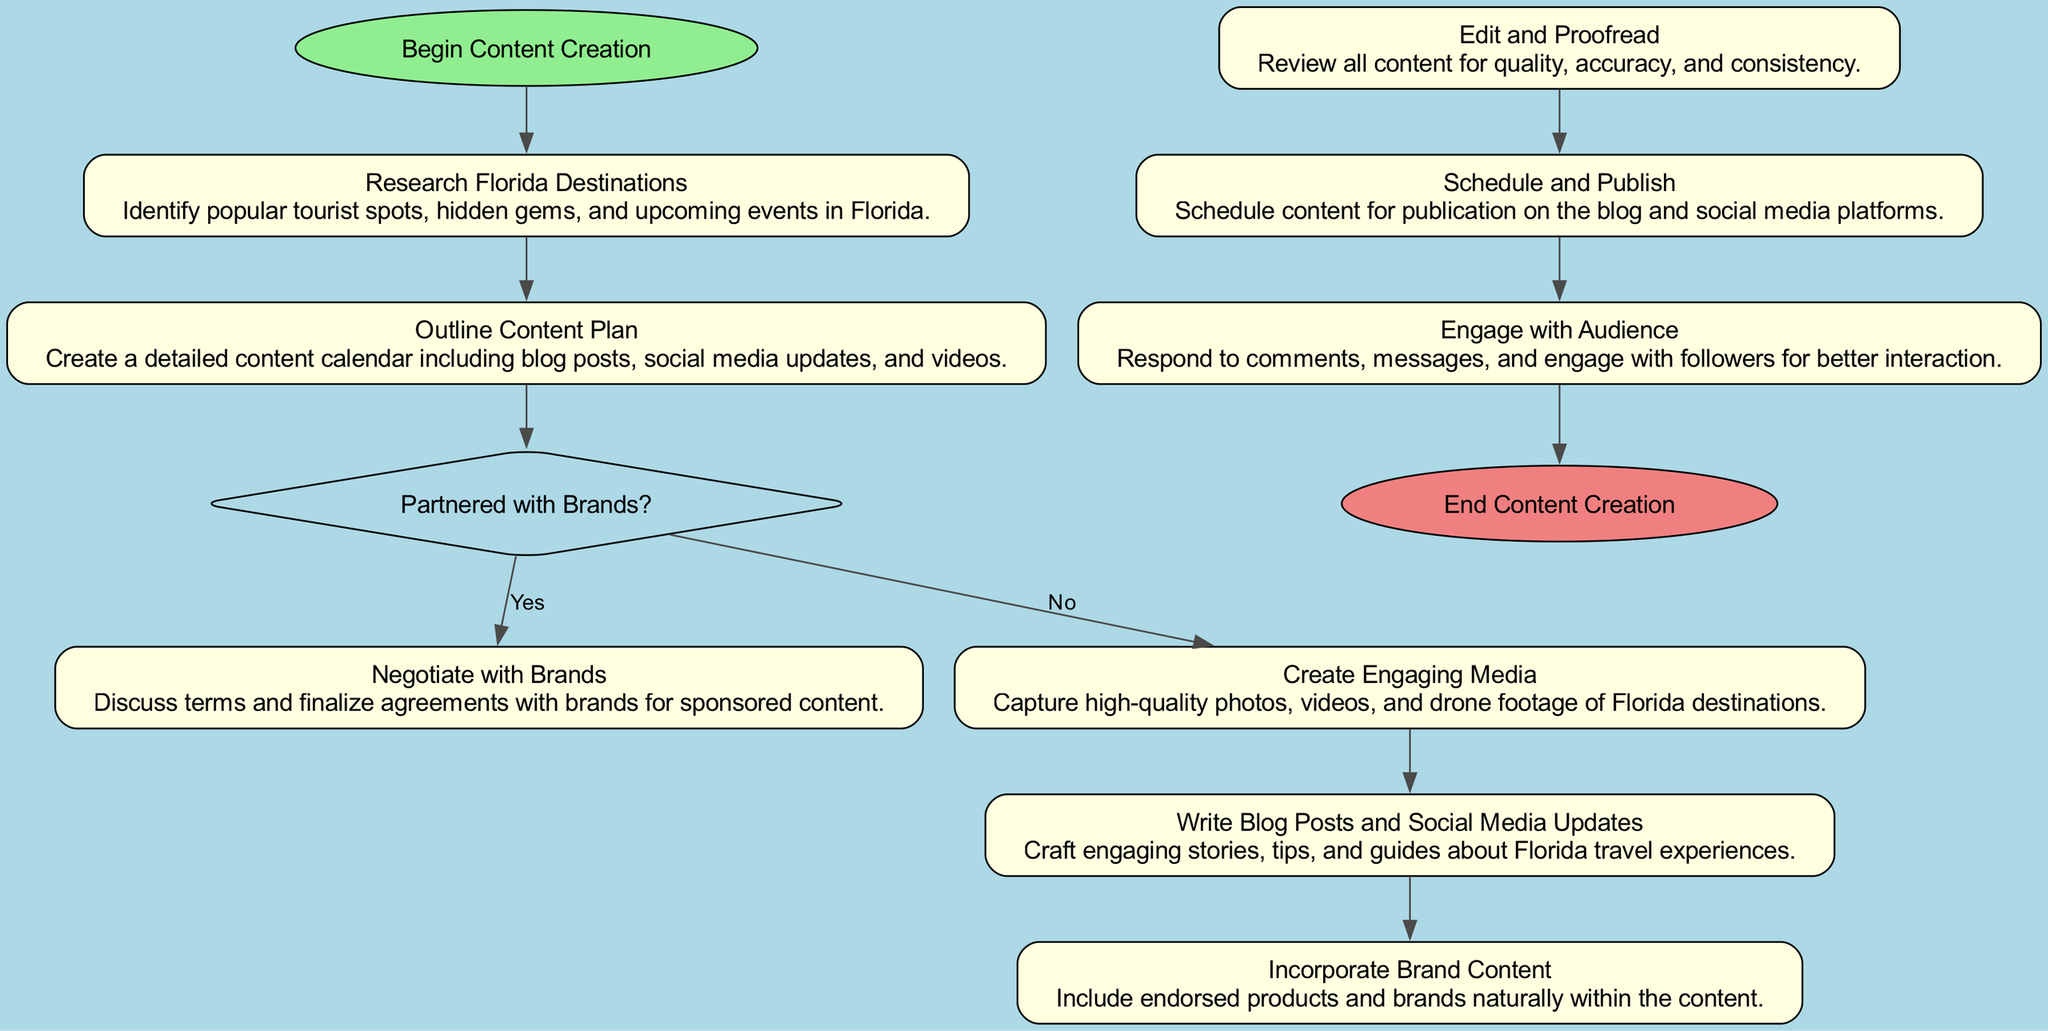What is the starting point of the workflow? The diagram indicates the starting point of the workflow as "Begin Content Creation", which is represented as a rounded node.
Answer: Begin Content Creation How many actions are listed in the workflow? Counting all the action nodes, we have six actions: "Research Florida Destinations", "Outline Content Plan", "Create Engaging Media", "Write Blog Posts and Social Media Updates", "Edit and Proofread", and "Schedule and Publish". Hence, there are six action nodes.
Answer: 6 What is the last action before the workflow ends? The last action before reaching the end node is "Engage with Audience", which is positioned directly before the end point in the diagram.
Answer: Engage with Audience Is there a decision point in the workflow? Yes, there is a decision point labeled "Partnered with Brands?", indicating whether brand partnerships are in effect. This is shown as a diamond-shaped node.
Answer: Yes What happens if the answer to "Partnered with Brands?" is yes? If the answer is yes, the next action is "Negotiate with Brands", followed by "Incorporate Brand Content" if applicable, which illustrates the flow from decision to specific actions based on the decision outcome.
Answer: Negotiate with Brands What type of node represents "Edit and Proofread"? This node is categorized as an action type, which is represented by a rectangular box according to the conventions in the diagram.
Answer: Action How many conditions are tied to the decision node? The decision node "Partnered with Brands?" has one condition attached to its actions: "yes". This is evident from the action nodes connected to the decision point depending on this condition.
Answer: 1 What is the purpose of "Outline Content Plan"? "Outline Content Plan" serves to create a structured content calendar, detailing the scheduled outputs such as blog posts, social media updates, and videos as an initial step after researching destinations.
Answer: Create a detailed content calendar Which node directly follows "Create Engaging Media"? The node that directly follows "Create Engaging Media" is "Write Blog Posts and Social Media Updates", indicating the sequential flow of the content creation process following media creation.
Answer: Write Blog Posts and Social Media Updates 